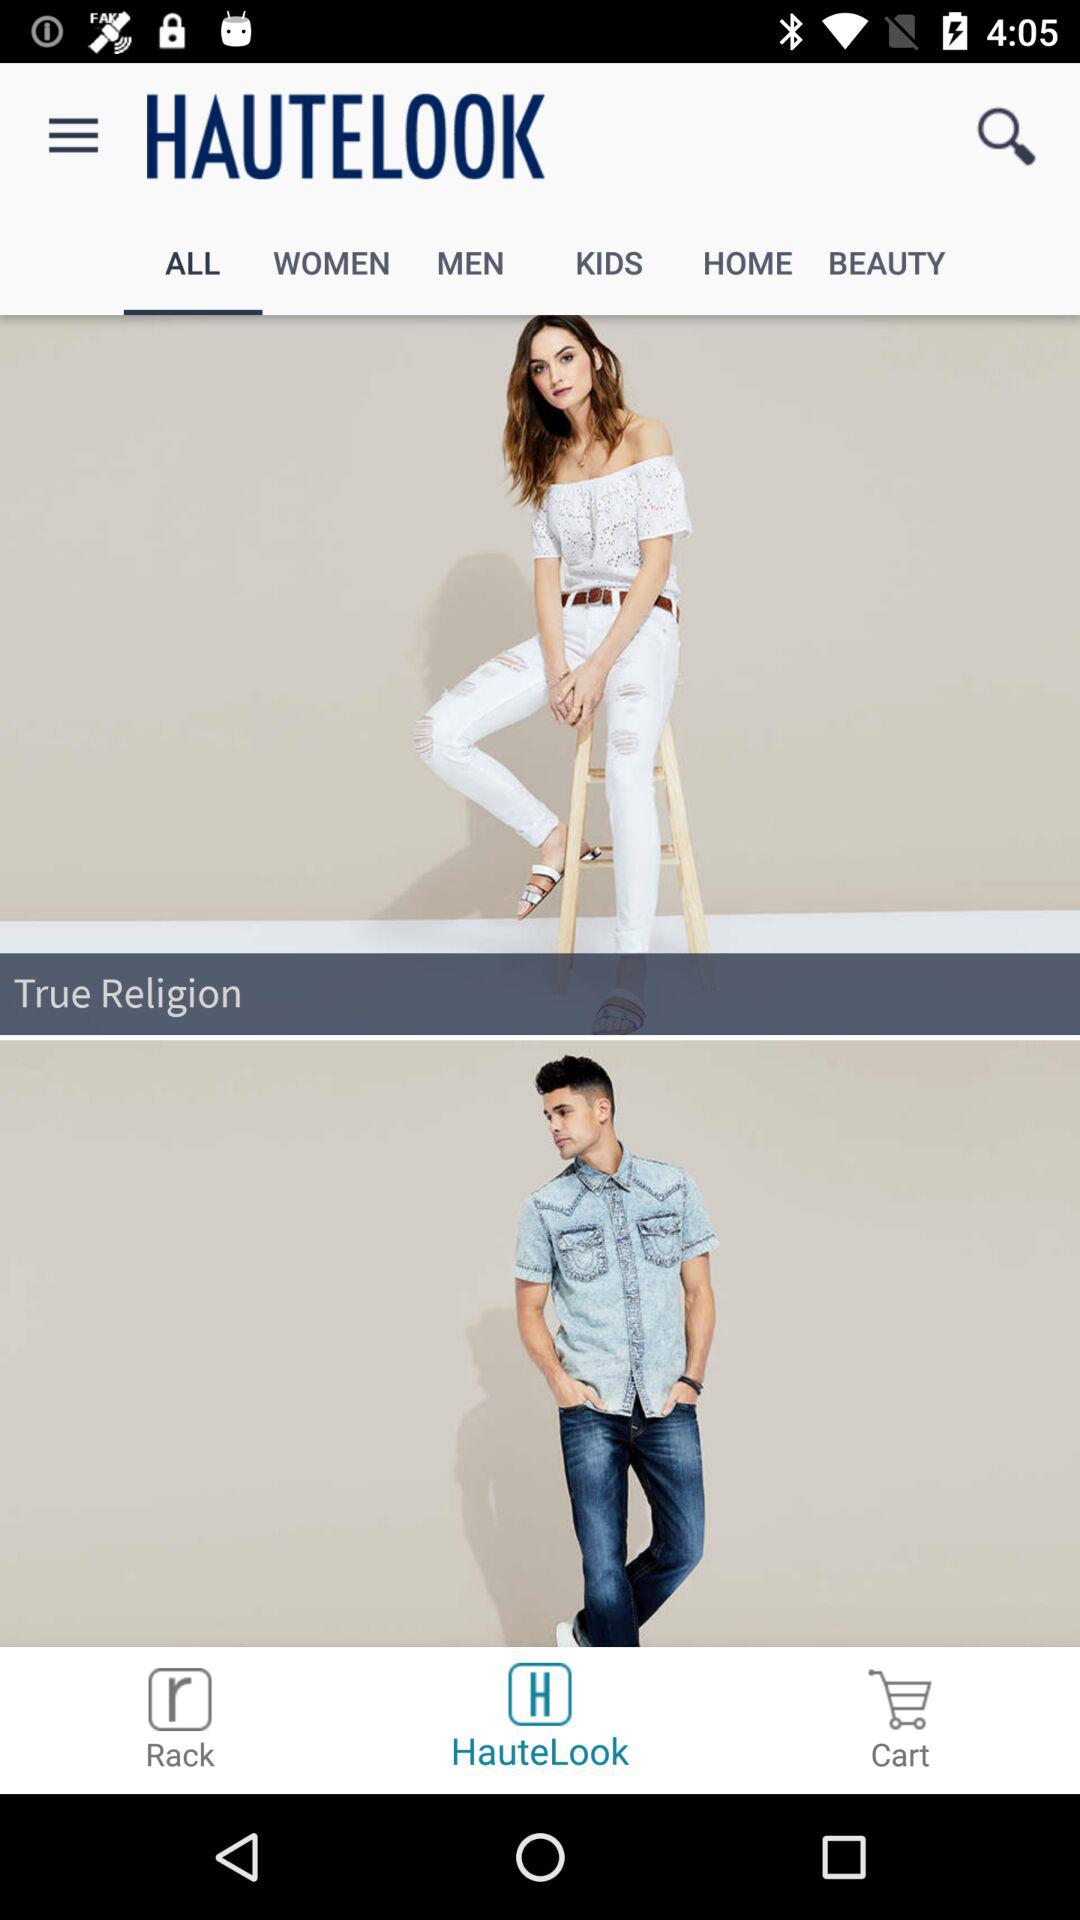What is the app name? The app name is "HAUTELOOK". 